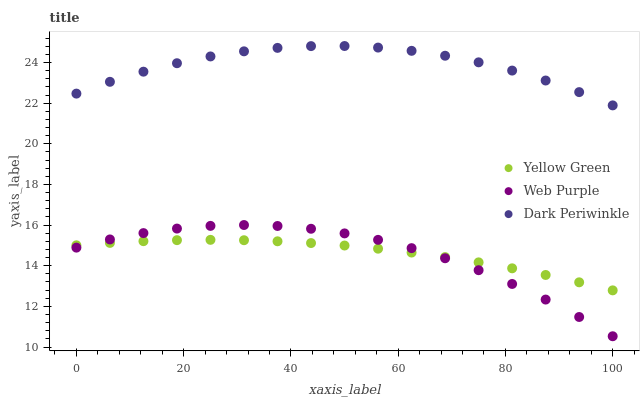Does Web Purple have the minimum area under the curve?
Answer yes or no. Yes. Does Dark Periwinkle have the maximum area under the curve?
Answer yes or no. Yes. Does Yellow Green have the minimum area under the curve?
Answer yes or no. No. Does Yellow Green have the maximum area under the curve?
Answer yes or no. No. Is Yellow Green the smoothest?
Answer yes or no. Yes. Is Web Purple the roughest?
Answer yes or no. Yes. Is Dark Periwinkle the smoothest?
Answer yes or no. No. Is Dark Periwinkle the roughest?
Answer yes or no. No. Does Web Purple have the lowest value?
Answer yes or no. Yes. Does Yellow Green have the lowest value?
Answer yes or no. No. Does Dark Periwinkle have the highest value?
Answer yes or no. Yes. Does Yellow Green have the highest value?
Answer yes or no. No. Is Web Purple less than Dark Periwinkle?
Answer yes or no. Yes. Is Dark Periwinkle greater than Web Purple?
Answer yes or no. Yes. Does Web Purple intersect Yellow Green?
Answer yes or no. Yes. Is Web Purple less than Yellow Green?
Answer yes or no. No. Is Web Purple greater than Yellow Green?
Answer yes or no. No. Does Web Purple intersect Dark Periwinkle?
Answer yes or no. No. 